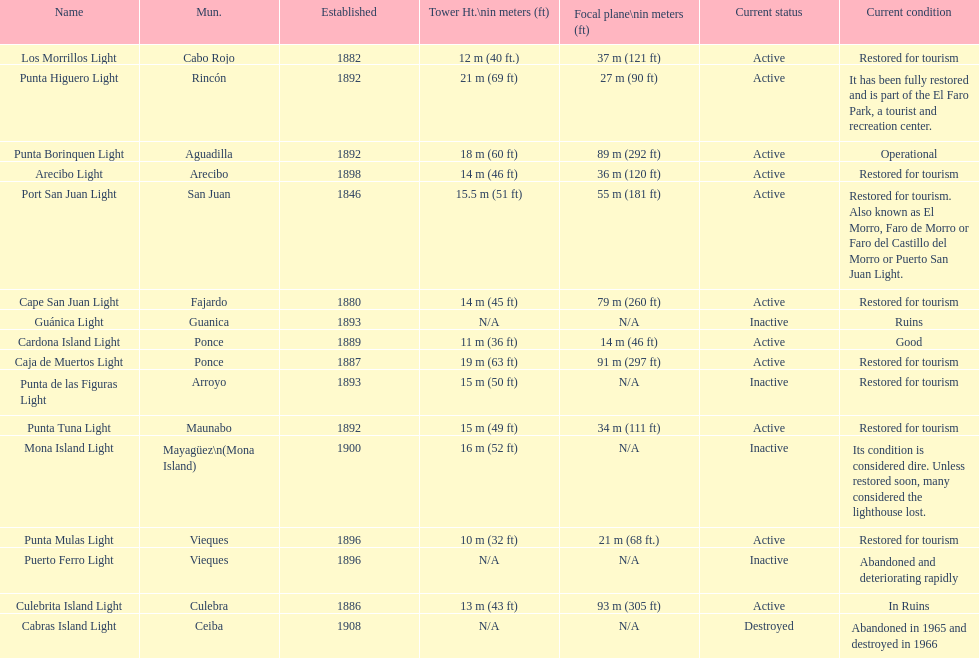Parse the full table. {'header': ['Name', 'Mun.', 'Established', 'Tower Ht.\\nin meters (ft)', 'Focal plane\\nin meters (ft)', 'Current status', 'Current condition'], 'rows': [['Los Morrillos Light', 'Cabo Rojo', '1882', '12\xa0m (40\xa0ft.)', '37\xa0m (121\xa0ft)', 'Active', 'Restored for tourism'], ['Punta Higuero Light', 'Rincón', '1892', '21\xa0m (69\xa0ft)', '27\xa0m (90\xa0ft)', 'Active', 'It has been fully restored and is part of the El Faro Park, a tourist and recreation center.'], ['Punta Borinquen Light', 'Aguadilla', '1892', '18\xa0m (60\xa0ft)', '89\xa0m (292\xa0ft)', 'Active', 'Operational'], ['Arecibo Light', 'Arecibo', '1898', '14\xa0m (46\xa0ft)', '36\xa0m (120\xa0ft)', 'Active', 'Restored for tourism'], ['Port San Juan Light', 'San Juan', '1846', '15.5\xa0m (51\xa0ft)', '55\xa0m (181\xa0ft)', 'Active', 'Restored for tourism. Also known as El Morro, Faro de Morro or Faro del Castillo del Morro or Puerto San Juan Light.'], ['Cape San Juan Light', 'Fajardo', '1880', '14\xa0m (45\xa0ft)', '79\xa0m (260\xa0ft)', 'Active', 'Restored for tourism'], ['Guánica Light', 'Guanica', '1893', 'N/A', 'N/A', 'Inactive', 'Ruins'], ['Cardona Island Light', 'Ponce', '1889', '11\xa0m (36\xa0ft)', '14\xa0m (46\xa0ft)', 'Active', 'Good'], ['Caja de Muertos Light', 'Ponce', '1887', '19\xa0m (63\xa0ft)', '91\xa0m (297\xa0ft)', 'Active', 'Restored for tourism'], ['Punta de las Figuras Light', 'Arroyo', '1893', '15\xa0m (50\xa0ft)', 'N/A', 'Inactive', 'Restored for tourism'], ['Punta Tuna Light', 'Maunabo', '1892', '15\xa0m (49\xa0ft)', '34\xa0m (111\xa0ft)', 'Active', 'Restored for tourism'], ['Mona Island Light', 'Mayagüez\\n(Mona Island)', '1900', '16\xa0m (52\xa0ft)', 'N/A', 'Inactive', 'Its condition is considered dire. Unless restored soon, many considered the lighthouse lost.'], ['Punta Mulas Light', 'Vieques', '1896', '10\xa0m (32\xa0ft)', '21\xa0m (68\xa0ft.)', 'Active', 'Restored for tourism'], ['Puerto Ferro Light', 'Vieques', '1896', 'N/A', 'N/A', 'Inactive', 'Abandoned and deteriorating rapidly'], ['Culebrita Island Light', 'Culebra', '1886', '13\xa0m (43\xa0ft)', '93\xa0m (305\xa0ft)', 'Active', 'In Ruins'], ['Cabras Island Light', 'Ceiba', '1908', 'N/A', 'N/A', 'Destroyed', 'Abandoned in 1965 and destroyed in 1966']]} Names of municipalities established before 1880 San Juan. 